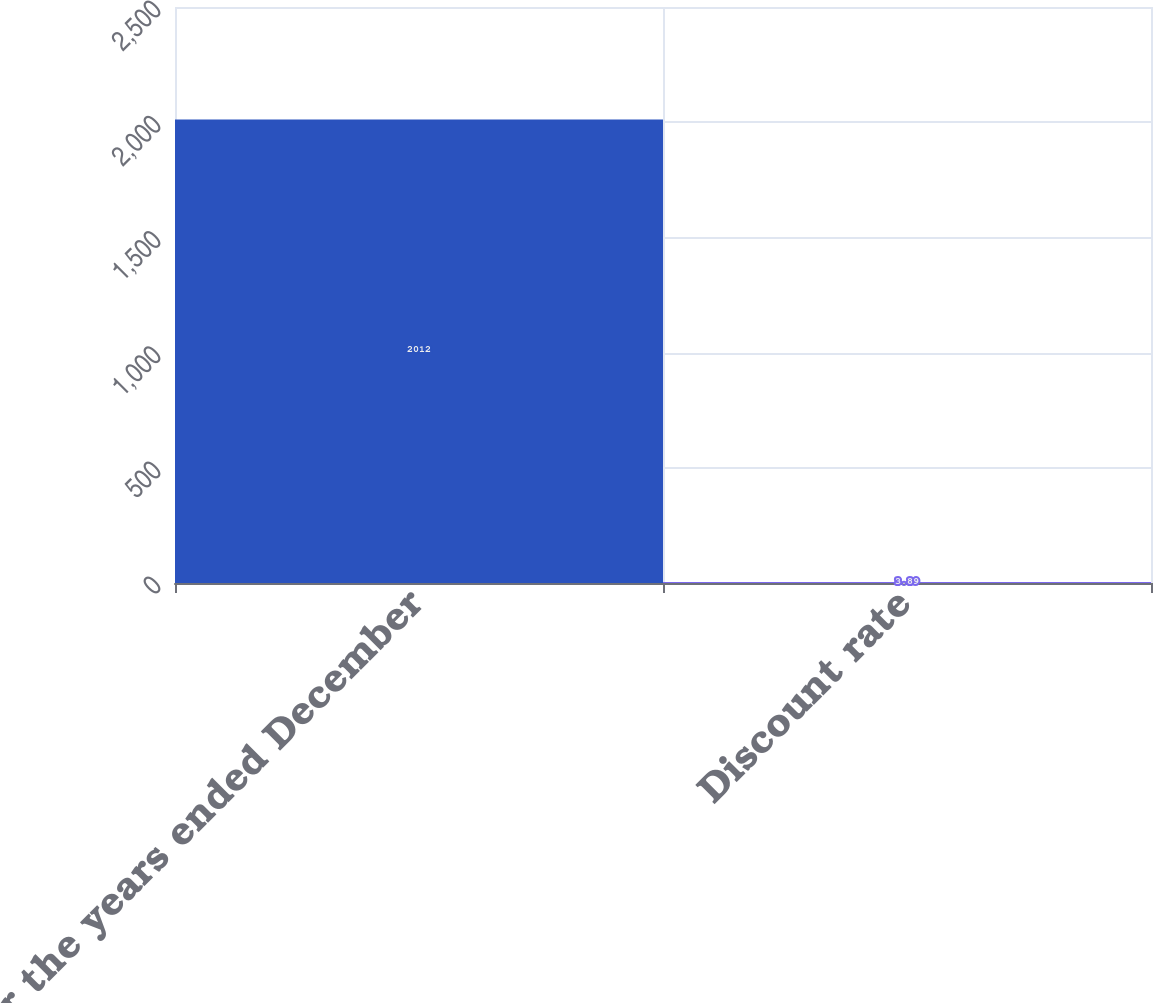<chart> <loc_0><loc_0><loc_500><loc_500><bar_chart><fcel>For the years ended December<fcel>Discount rate<nl><fcel>2012<fcel>3.89<nl></chart> 